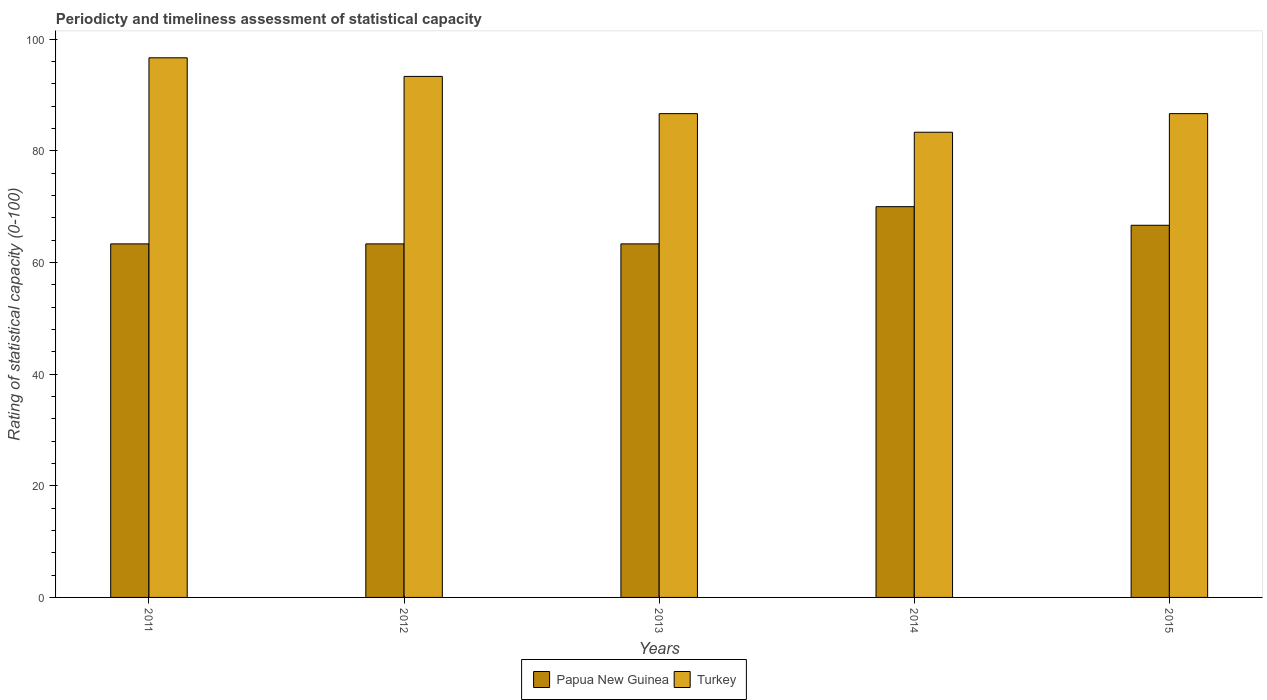How many different coloured bars are there?
Your answer should be compact. 2. How many groups of bars are there?
Your response must be concise. 5. Are the number of bars per tick equal to the number of legend labels?
Keep it short and to the point. Yes. Are the number of bars on each tick of the X-axis equal?
Give a very brief answer. Yes. How many bars are there on the 3rd tick from the left?
Offer a very short reply. 2. How many bars are there on the 1st tick from the right?
Provide a succinct answer. 2. What is the label of the 1st group of bars from the left?
Make the answer very short. 2011. What is the rating of statistical capacity in Turkey in 2012?
Keep it short and to the point. 93.33. Across all years, what is the maximum rating of statistical capacity in Papua New Guinea?
Offer a terse response. 70. Across all years, what is the minimum rating of statistical capacity in Turkey?
Ensure brevity in your answer.  83.33. In which year was the rating of statistical capacity in Turkey minimum?
Keep it short and to the point. 2014. What is the total rating of statistical capacity in Turkey in the graph?
Make the answer very short. 446.67. What is the difference between the rating of statistical capacity in Papua New Guinea in 2012 and that in 2015?
Provide a short and direct response. -3.33. What is the difference between the rating of statistical capacity in Papua New Guinea in 2015 and the rating of statistical capacity in Turkey in 2014?
Your response must be concise. -16.67. What is the average rating of statistical capacity in Papua New Guinea per year?
Make the answer very short. 65.33. In the year 2011, what is the difference between the rating of statistical capacity in Papua New Guinea and rating of statistical capacity in Turkey?
Offer a very short reply. -33.33. What is the ratio of the rating of statistical capacity in Turkey in 2012 to that in 2015?
Provide a succinct answer. 1.08. Is the rating of statistical capacity in Turkey in 2013 less than that in 2015?
Your answer should be very brief. Yes. What is the difference between the highest and the second highest rating of statistical capacity in Turkey?
Give a very brief answer. 3.33. What is the difference between the highest and the lowest rating of statistical capacity in Turkey?
Your response must be concise. 13.33. In how many years, is the rating of statistical capacity in Turkey greater than the average rating of statistical capacity in Turkey taken over all years?
Your answer should be compact. 2. What does the 1st bar from the right in 2011 represents?
Provide a succinct answer. Turkey. How many bars are there?
Ensure brevity in your answer.  10. Are all the bars in the graph horizontal?
Your answer should be compact. No. What is the difference between two consecutive major ticks on the Y-axis?
Ensure brevity in your answer.  20. Are the values on the major ticks of Y-axis written in scientific E-notation?
Provide a succinct answer. No. Where does the legend appear in the graph?
Your answer should be very brief. Bottom center. What is the title of the graph?
Give a very brief answer. Periodicty and timeliness assessment of statistical capacity. What is the label or title of the X-axis?
Provide a short and direct response. Years. What is the label or title of the Y-axis?
Make the answer very short. Rating of statistical capacity (0-100). What is the Rating of statistical capacity (0-100) in Papua New Guinea in 2011?
Your answer should be very brief. 63.33. What is the Rating of statistical capacity (0-100) in Turkey in 2011?
Your response must be concise. 96.67. What is the Rating of statistical capacity (0-100) in Papua New Guinea in 2012?
Your answer should be compact. 63.33. What is the Rating of statistical capacity (0-100) in Turkey in 2012?
Provide a short and direct response. 93.33. What is the Rating of statistical capacity (0-100) of Papua New Guinea in 2013?
Ensure brevity in your answer.  63.33. What is the Rating of statistical capacity (0-100) of Turkey in 2013?
Offer a terse response. 86.67. What is the Rating of statistical capacity (0-100) of Papua New Guinea in 2014?
Offer a very short reply. 70. What is the Rating of statistical capacity (0-100) of Turkey in 2014?
Your answer should be very brief. 83.33. What is the Rating of statistical capacity (0-100) in Papua New Guinea in 2015?
Provide a succinct answer. 66.67. What is the Rating of statistical capacity (0-100) of Turkey in 2015?
Your response must be concise. 86.67. Across all years, what is the maximum Rating of statistical capacity (0-100) in Papua New Guinea?
Your answer should be very brief. 70. Across all years, what is the maximum Rating of statistical capacity (0-100) in Turkey?
Your response must be concise. 96.67. Across all years, what is the minimum Rating of statistical capacity (0-100) of Papua New Guinea?
Make the answer very short. 63.33. Across all years, what is the minimum Rating of statistical capacity (0-100) of Turkey?
Make the answer very short. 83.33. What is the total Rating of statistical capacity (0-100) of Papua New Guinea in the graph?
Offer a terse response. 326.67. What is the total Rating of statistical capacity (0-100) of Turkey in the graph?
Your answer should be compact. 446.67. What is the difference between the Rating of statistical capacity (0-100) of Papua New Guinea in 2011 and that in 2013?
Offer a terse response. -0. What is the difference between the Rating of statistical capacity (0-100) of Papua New Guinea in 2011 and that in 2014?
Provide a short and direct response. -6.67. What is the difference between the Rating of statistical capacity (0-100) of Turkey in 2011 and that in 2014?
Give a very brief answer. 13.33. What is the difference between the Rating of statistical capacity (0-100) in Papua New Guinea in 2011 and that in 2015?
Give a very brief answer. -3.33. What is the difference between the Rating of statistical capacity (0-100) of Turkey in 2011 and that in 2015?
Keep it short and to the point. 10. What is the difference between the Rating of statistical capacity (0-100) in Papua New Guinea in 2012 and that in 2014?
Offer a terse response. -6.67. What is the difference between the Rating of statistical capacity (0-100) of Turkey in 2012 and that in 2014?
Provide a succinct answer. 10. What is the difference between the Rating of statistical capacity (0-100) in Papua New Guinea in 2012 and that in 2015?
Your answer should be very brief. -3.33. What is the difference between the Rating of statistical capacity (0-100) of Turkey in 2012 and that in 2015?
Your response must be concise. 6.67. What is the difference between the Rating of statistical capacity (0-100) in Papua New Guinea in 2013 and that in 2014?
Offer a very short reply. -6.67. What is the difference between the Rating of statistical capacity (0-100) of Papua New Guinea in 2013 and that in 2015?
Provide a succinct answer. -3.33. What is the difference between the Rating of statistical capacity (0-100) of Turkey in 2013 and that in 2015?
Your response must be concise. -0. What is the difference between the Rating of statistical capacity (0-100) in Papua New Guinea in 2014 and that in 2015?
Your answer should be very brief. 3.33. What is the difference between the Rating of statistical capacity (0-100) in Turkey in 2014 and that in 2015?
Ensure brevity in your answer.  -3.33. What is the difference between the Rating of statistical capacity (0-100) in Papua New Guinea in 2011 and the Rating of statistical capacity (0-100) in Turkey in 2012?
Make the answer very short. -30. What is the difference between the Rating of statistical capacity (0-100) of Papua New Guinea in 2011 and the Rating of statistical capacity (0-100) of Turkey in 2013?
Make the answer very short. -23.33. What is the difference between the Rating of statistical capacity (0-100) of Papua New Guinea in 2011 and the Rating of statistical capacity (0-100) of Turkey in 2014?
Provide a short and direct response. -20. What is the difference between the Rating of statistical capacity (0-100) in Papua New Guinea in 2011 and the Rating of statistical capacity (0-100) in Turkey in 2015?
Offer a terse response. -23.33. What is the difference between the Rating of statistical capacity (0-100) in Papua New Guinea in 2012 and the Rating of statistical capacity (0-100) in Turkey in 2013?
Ensure brevity in your answer.  -23.33. What is the difference between the Rating of statistical capacity (0-100) of Papua New Guinea in 2012 and the Rating of statistical capacity (0-100) of Turkey in 2015?
Provide a succinct answer. -23.33. What is the difference between the Rating of statistical capacity (0-100) in Papua New Guinea in 2013 and the Rating of statistical capacity (0-100) in Turkey in 2014?
Provide a short and direct response. -20. What is the difference between the Rating of statistical capacity (0-100) of Papua New Guinea in 2013 and the Rating of statistical capacity (0-100) of Turkey in 2015?
Your answer should be compact. -23.33. What is the difference between the Rating of statistical capacity (0-100) in Papua New Guinea in 2014 and the Rating of statistical capacity (0-100) in Turkey in 2015?
Offer a very short reply. -16.67. What is the average Rating of statistical capacity (0-100) in Papua New Guinea per year?
Offer a very short reply. 65.33. What is the average Rating of statistical capacity (0-100) in Turkey per year?
Ensure brevity in your answer.  89.33. In the year 2011, what is the difference between the Rating of statistical capacity (0-100) of Papua New Guinea and Rating of statistical capacity (0-100) of Turkey?
Ensure brevity in your answer.  -33.33. In the year 2013, what is the difference between the Rating of statistical capacity (0-100) in Papua New Guinea and Rating of statistical capacity (0-100) in Turkey?
Your answer should be compact. -23.33. In the year 2014, what is the difference between the Rating of statistical capacity (0-100) in Papua New Guinea and Rating of statistical capacity (0-100) in Turkey?
Keep it short and to the point. -13.33. What is the ratio of the Rating of statistical capacity (0-100) in Papua New Guinea in 2011 to that in 2012?
Provide a short and direct response. 1. What is the ratio of the Rating of statistical capacity (0-100) in Turkey in 2011 to that in 2012?
Your answer should be very brief. 1.04. What is the ratio of the Rating of statistical capacity (0-100) of Turkey in 2011 to that in 2013?
Ensure brevity in your answer.  1.12. What is the ratio of the Rating of statistical capacity (0-100) in Papua New Guinea in 2011 to that in 2014?
Your answer should be compact. 0.9. What is the ratio of the Rating of statistical capacity (0-100) in Turkey in 2011 to that in 2014?
Provide a short and direct response. 1.16. What is the ratio of the Rating of statistical capacity (0-100) of Turkey in 2011 to that in 2015?
Provide a short and direct response. 1.12. What is the ratio of the Rating of statistical capacity (0-100) of Papua New Guinea in 2012 to that in 2014?
Ensure brevity in your answer.  0.9. What is the ratio of the Rating of statistical capacity (0-100) in Turkey in 2012 to that in 2014?
Offer a very short reply. 1.12. What is the ratio of the Rating of statistical capacity (0-100) in Turkey in 2012 to that in 2015?
Offer a very short reply. 1.08. What is the ratio of the Rating of statistical capacity (0-100) in Papua New Guinea in 2013 to that in 2014?
Your answer should be compact. 0.9. What is the ratio of the Rating of statistical capacity (0-100) in Turkey in 2013 to that in 2014?
Keep it short and to the point. 1.04. What is the ratio of the Rating of statistical capacity (0-100) of Turkey in 2013 to that in 2015?
Make the answer very short. 1. What is the ratio of the Rating of statistical capacity (0-100) of Turkey in 2014 to that in 2015?
Make the answer very short. 0.96. What is the difference between the highest and the second highest Rating of statistical capacity (0-100) in Papua New Guinea?
Keep it short and to the point. 3.33. What is the difference between the highest and the second highest Rating of statistical capacity (0-100) in Turkey?
Offer a very short reply. 3.33. What is the difference between the highest and the lowest Rating of statistical capacity (0-100) of Papua New Guinea?
Ensure brevity in your answer.  6.67. What is the difference between the highest and the lowest Rating of statistical capacity (0-100) of Turkey?
Give a very brief answer. 13.33. 